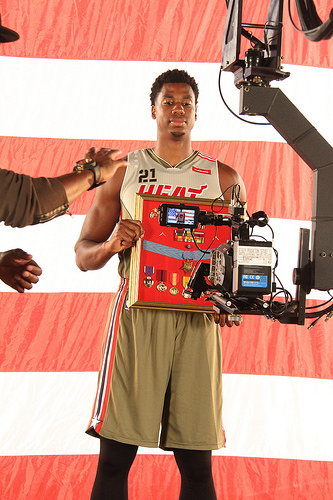<image>
Is the camera in front of the man? Yes. The camera is positioned in front of the man, appearing closer to the camera viewpoint. 